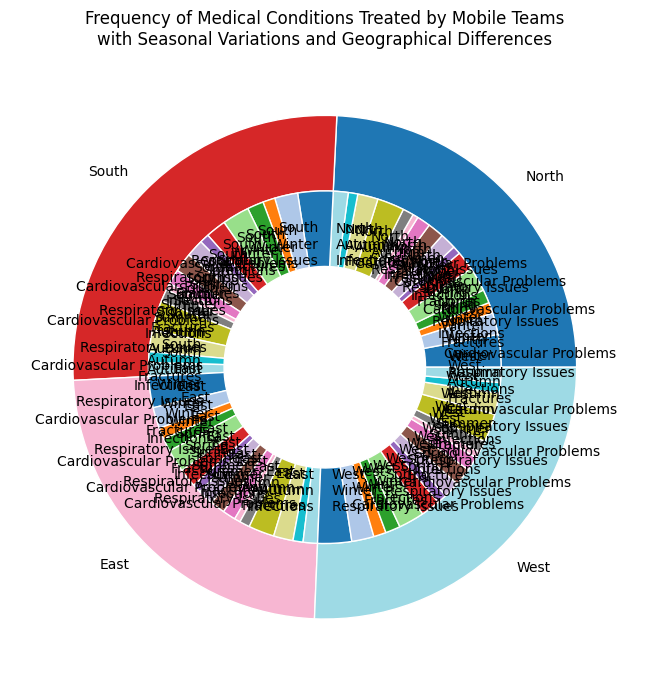Which region has the highest frequency of Respiratory Issues in Winter? Look at the outer ring for each region and then find the sub-section that represents Respiratory Issues in Winter. Compare the sizes of these sections to determine the largest one.
Answer: South What is the total frequency of Cardiovascular Problems in the North region across all seasons? Sum the frequencies for Cardiovascular Problems in the North for Winter, Spring, Summer, and Autumn. The frequencies are 80, 70, 50, and 75 respectively, so the total is 80 + 70 + 50 + 75.
Answer: 275 Which season in the West region has the lowest frequency of medical conditions treated? Compare the inner wedge sizes across all seasons (Winter, Spring, Summer, Autumn) for the West region. The smallest wedge represents the season with the lowest frequency.
Answer: Summer In the East region, how does the frequency of Fractures differ between Winter and Summer? Find the wedges for Fractures in Winter and Summer within the East region. Subtract the frequency in Summer from the frequency in Winter (42 - 22).
Answer: 20 How does the frequency of Infections in Spring compare between the North and South regions? Locate the sub-sections for Infections in Spring for both the North and South regions, and compare their frequencies directly.
Answer: South > North Which region has the smallest combined frequency of Respiratory Issues and Cardiovascular Problems in Autumn? For each region, sum the frequencies of Respiratory Issues and Cardiovascular Problems in Autumn. Compare these sums and identify the smallest one.
Answer: East What is the average frequency of Fractures treated in the West region over all seasons? Sum the frequencies of Fractures in all seasons in the West (46 + 36 + 24 + 39) and divide by the number of seasons (4). The average is (46 + 36 + 24 + 39) / 4.
Answer: 36.25 Which region shows the biggest seasonal variation in Respiratory Issues treatment frequency? Calculate the range (maximum frequency - minimum frequency) of Respiratory Issues treated in each region and compare these ranges. The region with the highest range shows the biggest variation.
Answer: South 